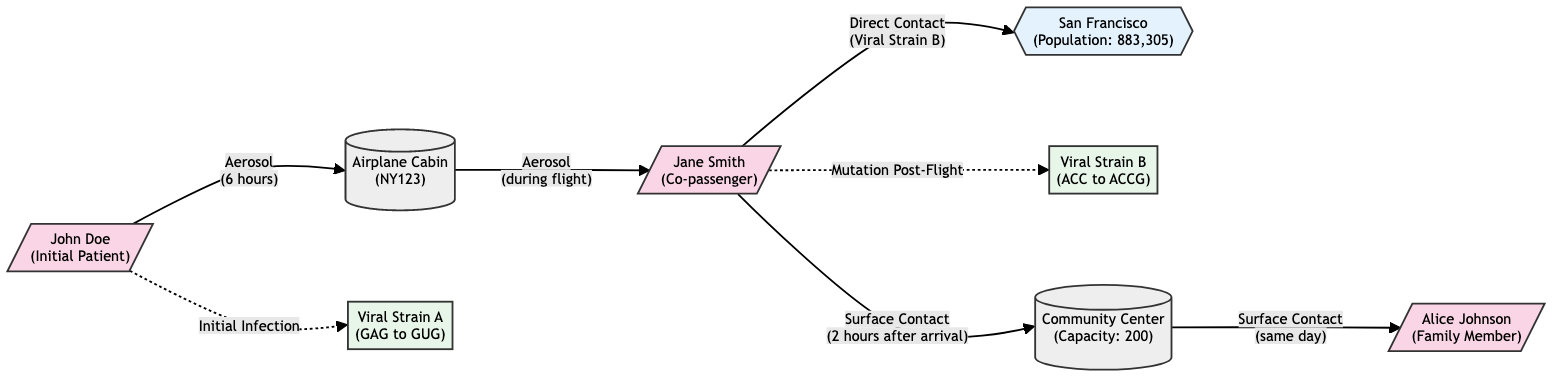What is the role of John Doe in the diagram? The diagram indicates that John Doe is labeled as the "Initial Patient," which means he is the first identified individual in the context of the viral infection spread.
Answer: Initial Patient How many nodes are represented in the diagram? By counting the unique nodes present, we can observe that there are a total of 8 nodes, which include humans, environments, locations, and genetic sequences.
Answer: 8 What is the transmission mode from the Airplane Cabin to Jane Smith? The diagram shows the edge from the Airplane Cabin to Jane Smith, stating that the transmission mode is "Aerosol" occurring "during flight."
Answer: Aerosol Which viral strain was associated with Jane Smith? In the diagram, the edge leading from Jane Smith is labeled with the association of "Mutation Post-Flight," indicating that Jane Smith is connected to "Viral Strain B."
Answer: Viral Strain B What type of mutation is represented by Viral Strain A? The diagram describes Viral Strain A as having a "Point Mutation," indicated by the specific codon change from "GAG to GUG."
Answer: Point Mutation What environment did Jane Smith visit after arriving in San Francisco? The diagram shows that after Jane Smith arrives in San Francisco, she interacts with the "Community Center," which is identified as a public place.
Answer: Community Center How long was John Doe in the Airplane Cabin? The edge connecting John Doe to the Airplane Cabin indicates that he spent "6 hours" in this environment, according to the transmission mode details described.
Answer: 6 hours What type of contact transmitted the virus from Jane Smith to Alice Johnson? The diagram indicates that Alice Johnson contracted the virus through "Surface Contact," as shown by the edge connecting the Community Center to her.
Answer: Surface Contact What was the time frame for surface contact between the Community Center and Alice Johnson? The diagram specifies that the contact with Alice Johnson occurred "same day," indicating a prompt transmission after Jane's visit to the Community Center.
Answer: Same day 